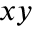Convert formula to latex. <formula><loc_0><loc_0><loc_500><loc_500>x y</formula> 